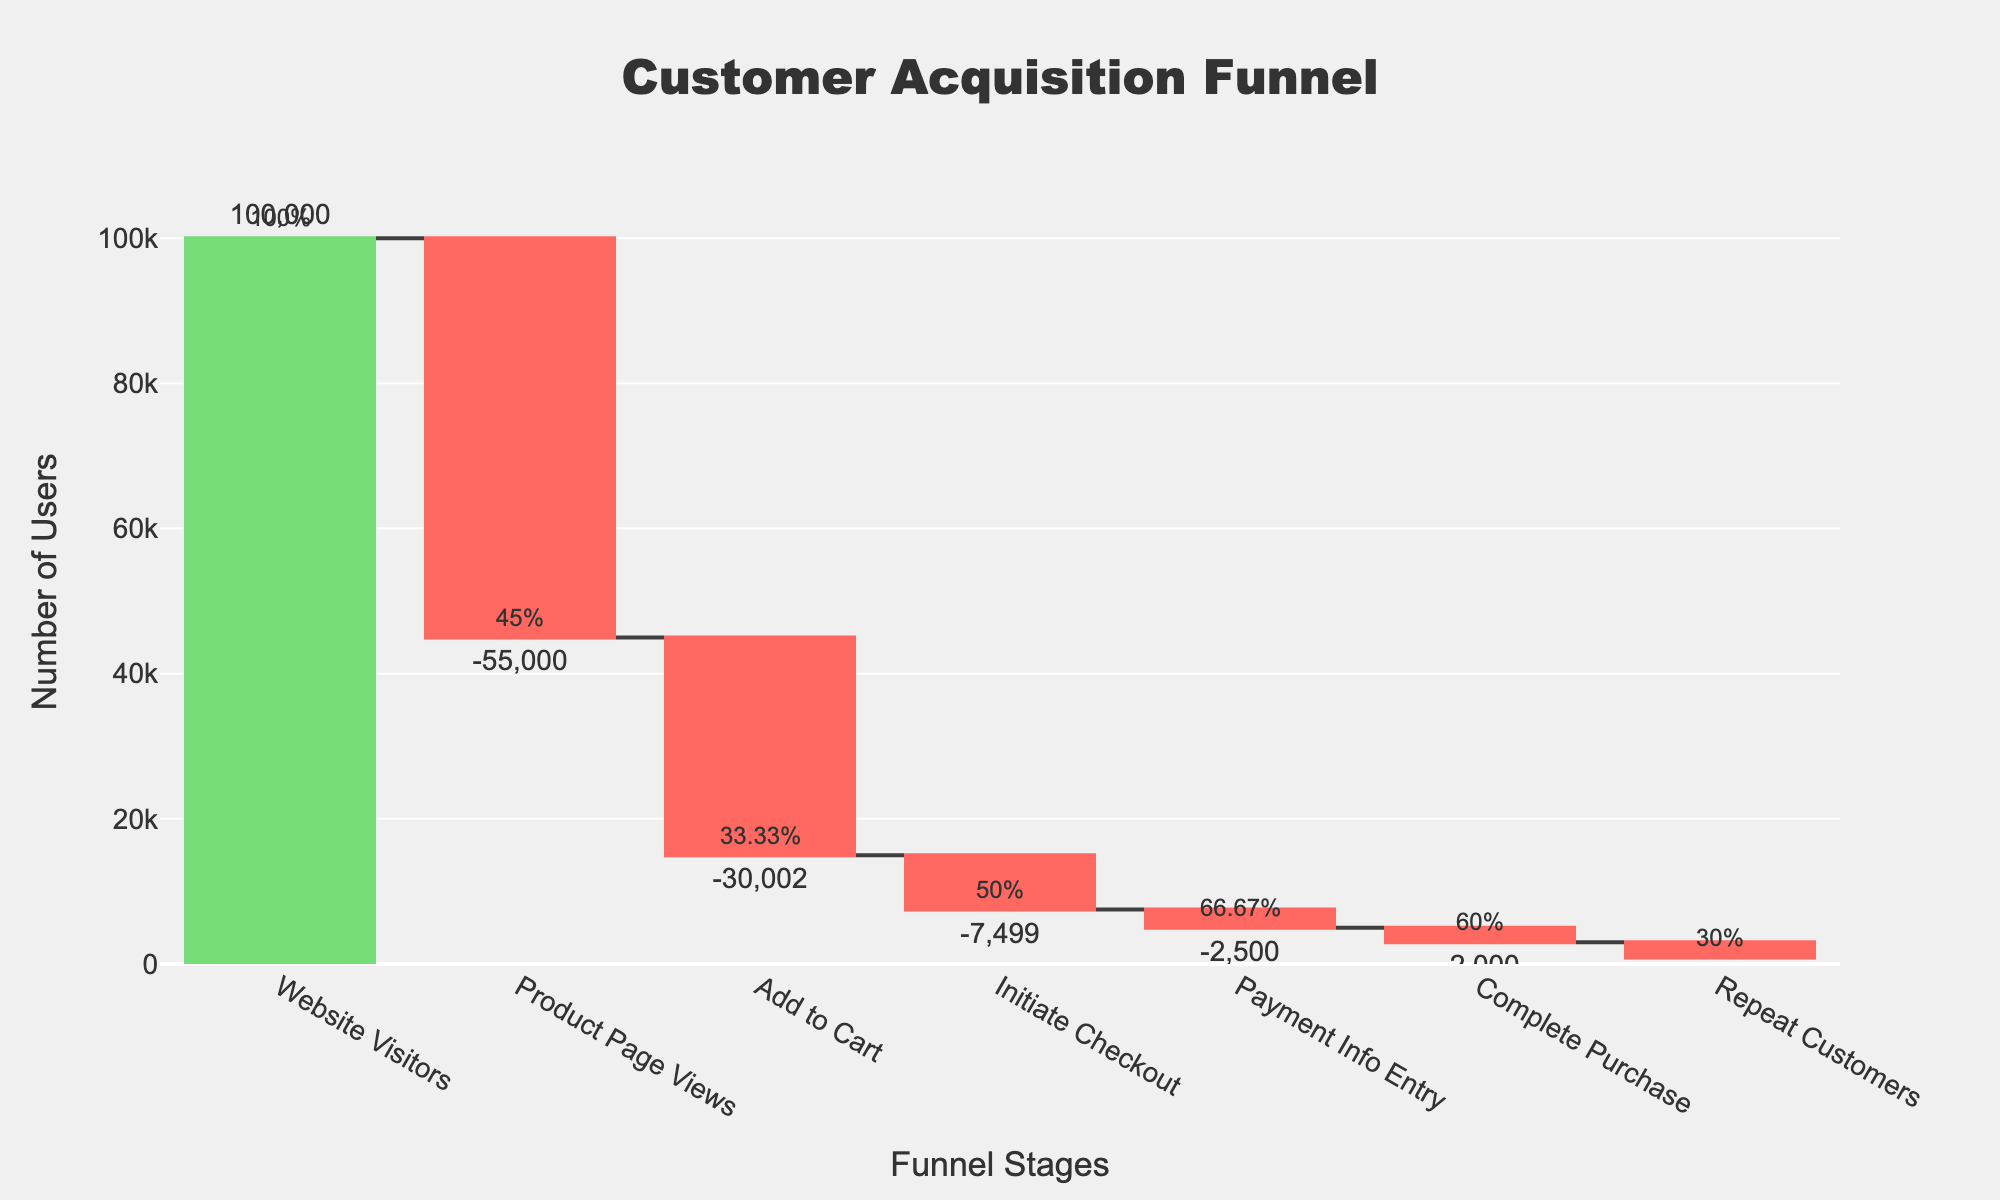How many users viewed the product page? The data shows the cumulative number of users at each stage. The ‘Product Page Views’ stage has 45,000 users.
Answer: 45,000 Which stage has the highest conversion rate? By looking at the conversion rates annotated on the plot, the 'Payment Info Entry' stage has the highest rate at 66.67%.
Answer: Payment Info Entry What is the total drop-off from ‘Website Visitors’ to ‘Complete Purchase’? The difference between 'Website Visitors' (100,000) and 'Complete Purchase' (3,000) users is 100,000 - 3,000.
Answer: 97,000 Compared to the previous stage, which stage has the smallest number of users advancing? By examining the differences in user counts between stages, the smallest difference is between 'Add to Cart' (15,000) and 'Initiate Checkout' (7,500), which is 7,500 users.
Answer: Initiate Checkout What percentage of users who initiated checkout completed the purchase? Calculated by dividing 'Complete Purchase' users (3,000) by 'Initiate Checkout' users (7,500) and multiplying by 100: (3,000 / 7,500) * 100 = 40%.
Answer: 40% How many repeat customers are there as a percentage of completed purchases? Dividing 'Repeat Customers' (900) by 'Complete Purchase' users (3,000) and multiplying by 100 gives: (900 / 3,000) * 100 = 30%.
Answer: 30% What stage features the largest drop-off in user count? By comparing the differences in user counts between successive stages, the largest drop-off occurs between 'Website Visitors' (100,000) and 'Product Page Views' (45,000), a drop of 55,000 users.
Answer: Product Page Views How many users viewed the product page but did not add it to the cart? The difference between 'Product Page Views' (45,000) and 'Add to Cart' (15,000) is 45,000 - 15,000.
Answer: 30,000 What is the total conversion rate from 'Website Visitors' to 'Complete Purchase'? By applying the cumulative conversion rate at the last stage ('Complete Purchase'), it is 3,000 / 100,000 * 100%.
Answer: 3% Is the conversion rate from ‘Add to Cart’ to ‘Initiate Checkout’ more than or less than 50%? The chart shows the conversion rate from 'Add to Cart' (15,000) to 'Initiate Checkout' (7,500) is 50%.
Answer: Equal to 50% 